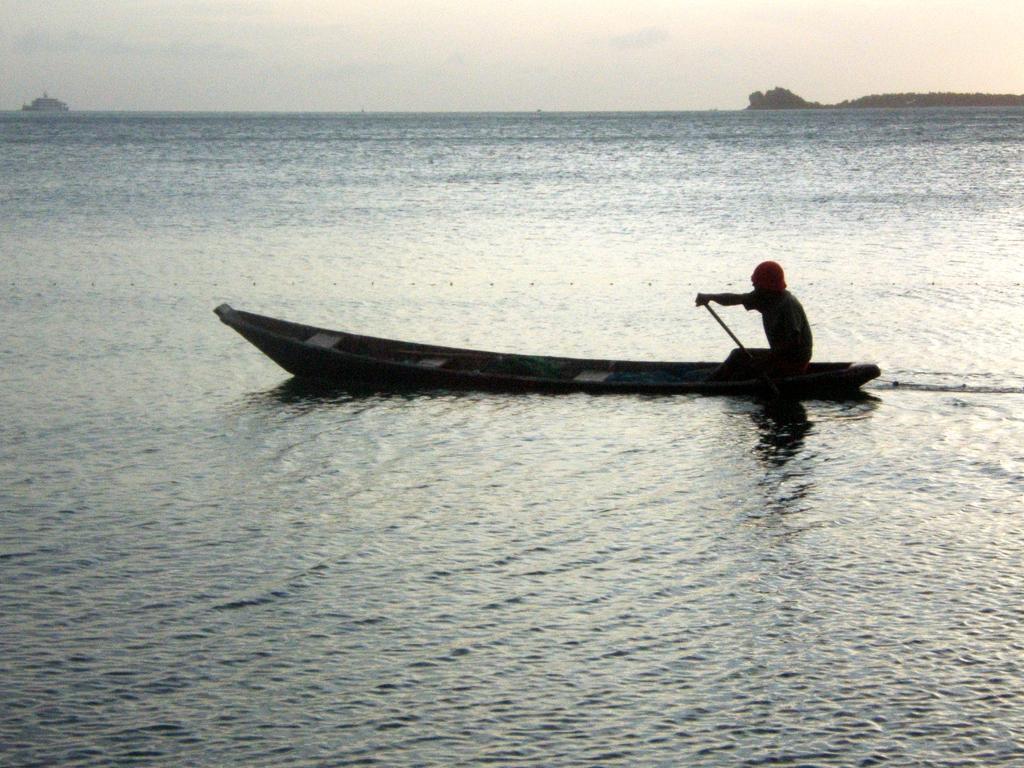Can you describe this image briefly? There is a person sitting on a boat and riding it on the water of an ocean. In the background, there is a ship on the water, there is a mountain and there are clouds in the sky. 